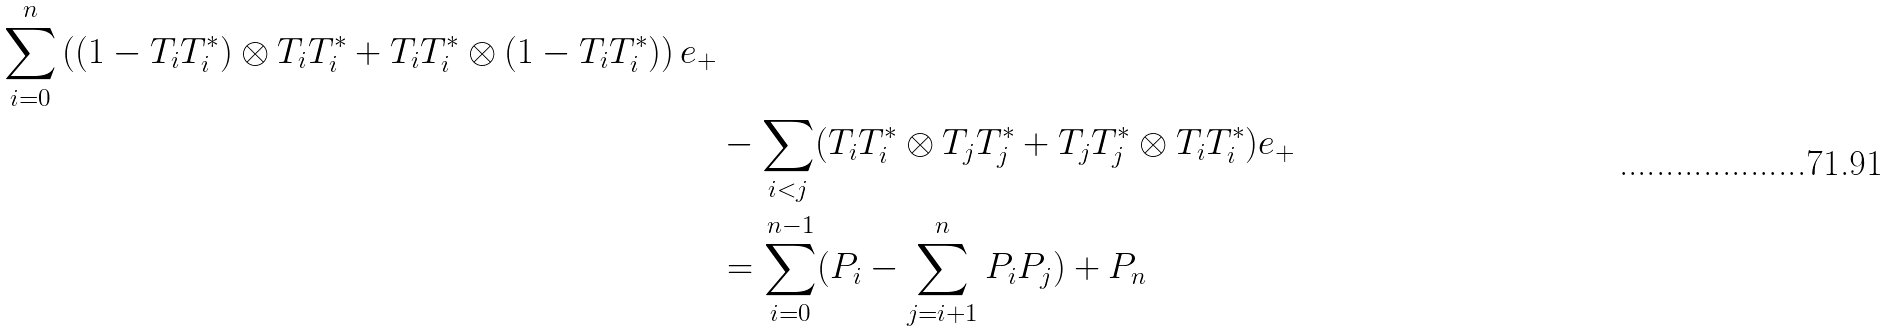<formula> <loc_0><loc_0><loc_500><loc_500>{ \sum _ { i = 0 } ^ { n } \left ( ( 1 - T _ { i } T _ { i } ^ { * } ) \otimes T _ { i } T _ { i } ^ { * } + T _ { i } T _ { i } ^ { * } \otimes ( 1 - T _ { i } T _ { i } ^ { * } ) \right ) e _ { + } } \\ & - \sum _ { i < j } ( T _ { i } T _ { i } ^ { * } \otimes T _ { j } T _ { j } ^ { * } + T _ { j } T _ { j } ^ { * } \otimes T _ { i } T _ { i } ^ { * } ) e _ { + } \\ & = \sum _ { i = 0 } ^ { n - 1 } ( P _ { i } - \sum _ { j = i + 1 } ^ { n } P _ { i } P _ { j } ) + P _ { n }</formula> 